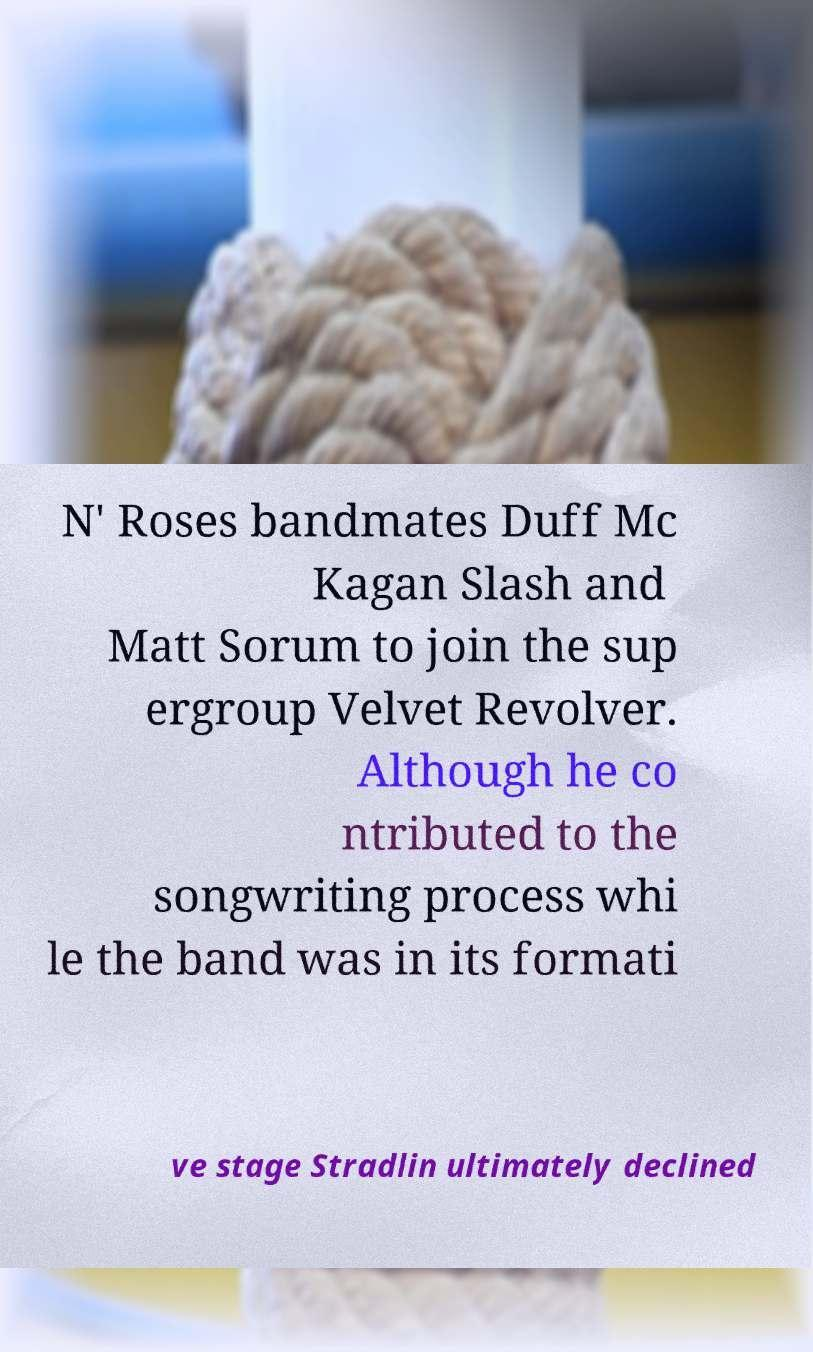Could you assist in decoding the text presented in this image and type it out clearly? N' Roses bandmates Duff Mc Kagan Slash and Matt Sorum to join the sup ergroup Velvet Revolver. Although he co ntributed to the songwriting process whi le the band was in its formati ve stage Stradlin ultimately declined 